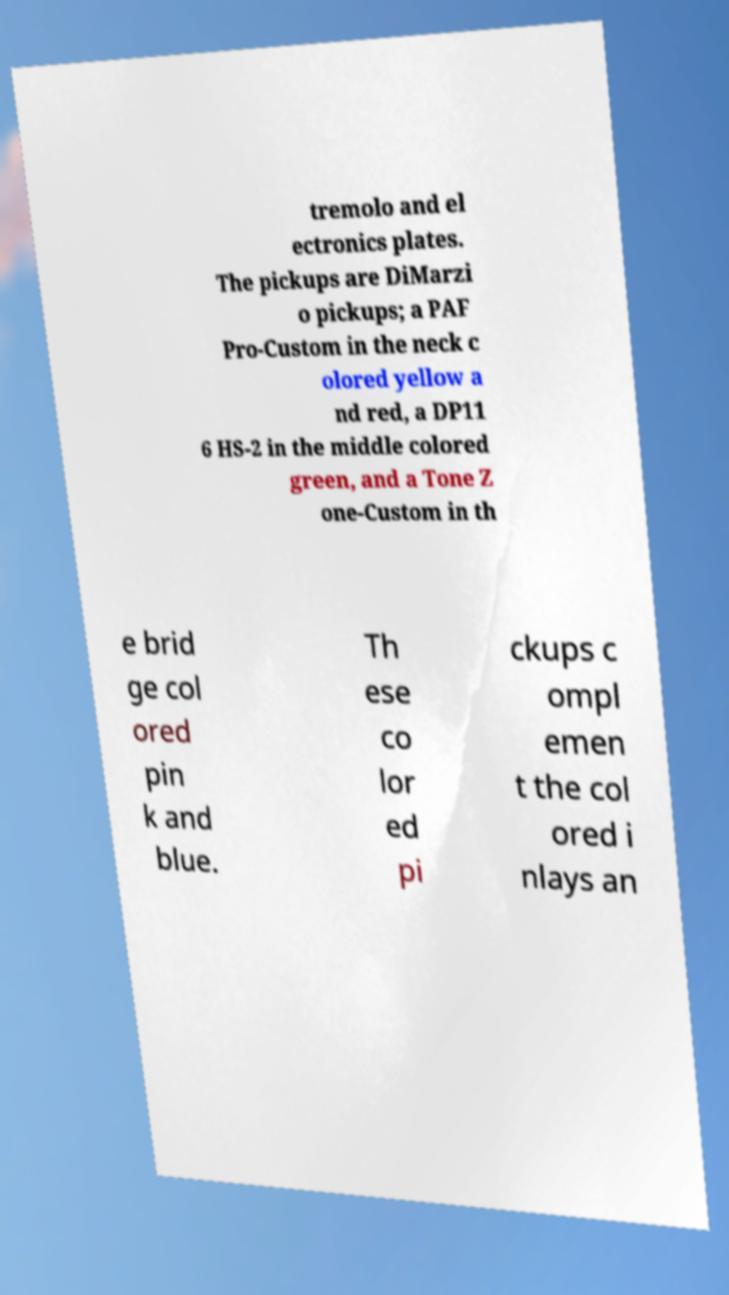For documentation purposes, I need the text within this image transcribed. Could you provide that? tremolo and el ectronics plates. The pickups are DiMarzi o pickups; a PAF Pro-Custom in the neck c olored yellow a nd red, a DP11 6 HS-2 in the middle colored green, and a Tone Z one-Custom in th e brid ge col ored pin k and blue. Th ese co lor ed pi ckups c ompl emen t the col ored i nlays an 